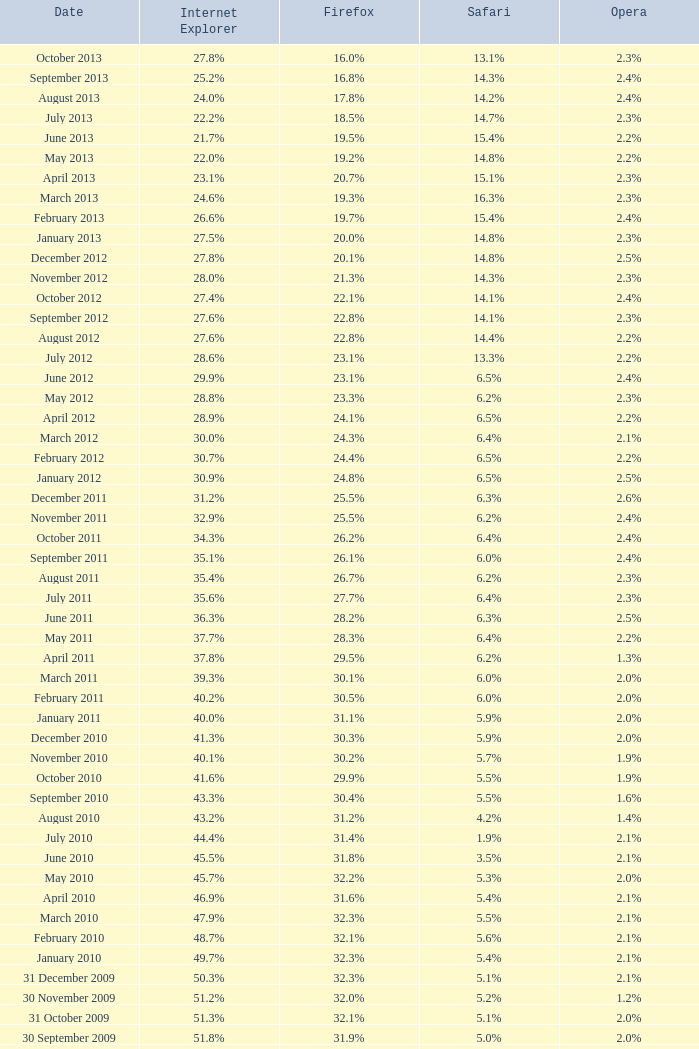What is the firefox valuation with a 25.1%. 